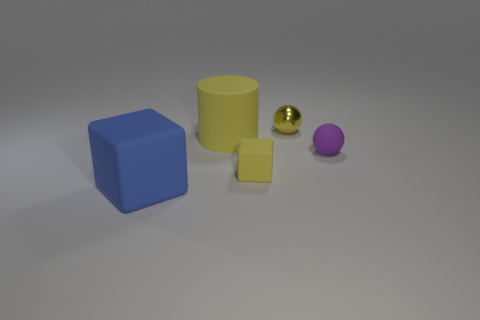What number of tiny objects are either green things or blue cubes?
Provide a short and direct response. 0. What material is the tiny yellow sphere?
Your answer should be very brief. Metal. What is the small object that is to the right of the yellow block and to the left of the tiny purple matte thing made of?
Your answer should be very brief. Metal. Does the big cylinder have the same color as the tiny matte object that is in front of the purple matte thing?
Offer a very short reply. Yes. There is a yellow ball that is the same size as the purple object; what is its material?
Offer a very short reply. Metal. Are there any other yellow cylinders made of the same material as the yellow cylinder?
Keep it short and to the point. No. What number of tiny brown matte cubes are there?
Offer a very short reply. 0. Does the big cylinder have the same material as the cube that is to the left of the cylinder?
Provide a succinct answer. Yes. There is a large thing that is the same color as the tiny block; what is it made of?
Provide a succinct answer. Rubber. What number of large matte cubes have the same color as the large cylinder?
Give a very brief answer. 0. 